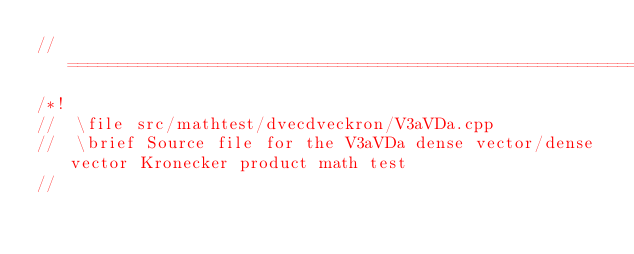<code> <loc_0><loc_0><loc_500><loc_500><_C++_>//=================================================================================================
/*!
//  \file src/mathtest/dvecdveckron/V3aVDa.cpp
//  \brief Source file for the V3aVDa dense vector/dense vector Kronecker product math test
//</code> 